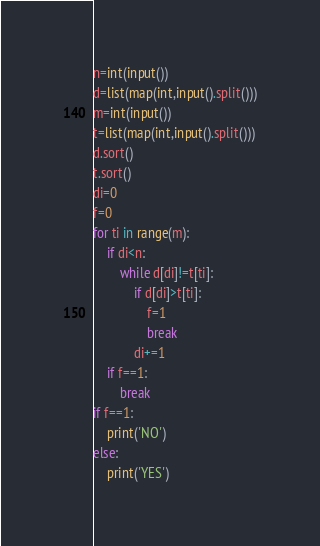Convert code to text. <code><loc_0><loc_0><loc_500><loc_500><_Python_>n=int(input())
d=list(map(int,input().split()))
m=int(input())
t=list(map(int,input().split()))
d.sort()
t.sort()
di=0
f=0
for ti in range(m):
    if di<n:
        while d[di]!=t[ti]:
            if d[di]>t[ti]:
                f=1
                break
            di+=1
    if f==1:
        break
if f==1:
    print('NO')
else:
    print('YES')</code> 